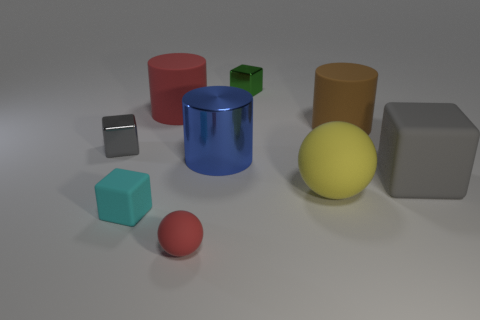Considering the lighting in this image, can you describe the direction and quality of the light source? The light source appears to be coming from the upper left of the frame, as indicated by the shadows cast towards the bottom right. The quality of light is soft, creating gentle shadows and subtle highlights without harsh contrasts, suggesting there may be a diffuser or other scattering medium involved. 